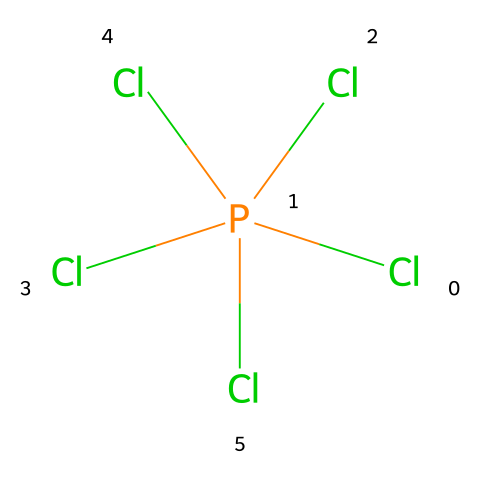What is the central atom in this compound? The visual representation shows the phosphorus atom, which is linked to five chlorine atoms, placing it at the center.
Answer: phosphorus How many chlorine atoms are present in the structure? Counting from the SMILES notation, there are five 'Cl' labels indicating five chlorine atoms in the molecule.
Answer: five What is the formal charge of phosphorus in this molecule? In phosphorus pentachloride, phosphorus typically has five bonds (one to each chlorine), indicating it has a formal charge of zero when considering its valence electrons.
Answer: zero Is this compound an example of a hypervalent molecule? Yes, because phosphorus is bonded to more than four other atoms, making it hypervalent according to VSEPR theory and the understanding of coordination numbers.
Answer: yes What type of hybridization does the phosphorus atom exhibit in this structure? The phosphorus atom in PCl5 exhibits sp3d hybridization as it makes five equivalent bonds with the chlorine atoms.
Answer: sp3d What molecular geometry does phosphorus pentachloride have? The arrangement of five atoms around the central phosphorus leads to a trigonal bipyramidal geometry, which is characteristic for compounds with five bonded pairs.
Answer: trigonal bipyramidal What is the primary use of phosphorus pentachloride in chemistry? It is primarily used as a chlorinating agent in organic synthesis, allowing for the introduction of chlorine into organic compounds.
Answer: chlorinating agent 